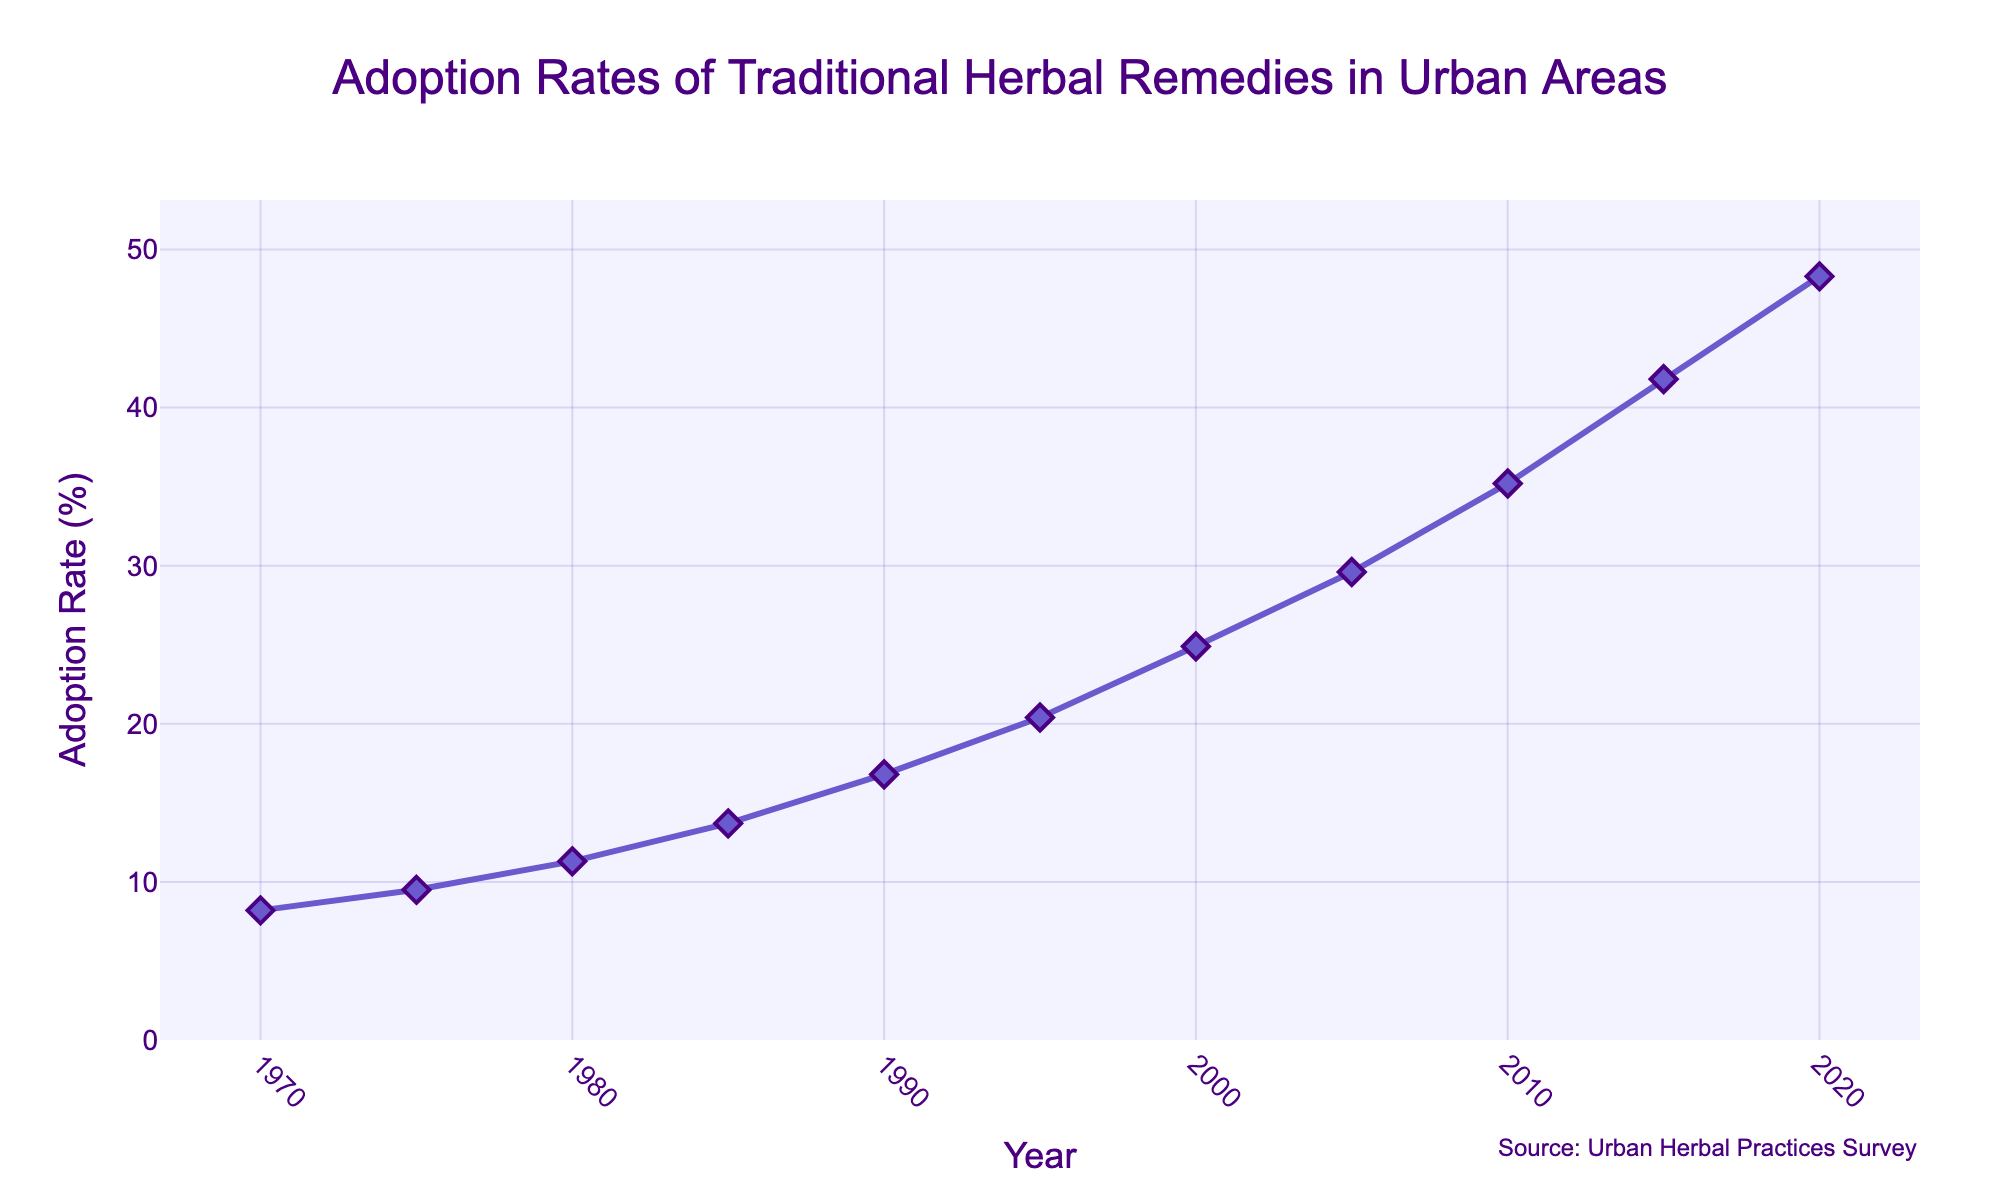What's the overall trend of the adoption rate of traditional herbal remedies in urban areas over the past 50 years? The line chart shows a consistent upward trend in the adoption rate of traditional herbal remedies from 1970 to 2020. Each segment between data points shows an increase without any decline.
Answer: Increasing In which decade did the adoption rate of traditional herbal remedies increase the most? To determine the decade with the highest increase, subtract the adoption rate of the starting year of each decade from the ending year. The decade with the largest difference is the one with the most significant increase. 2010-2020 shows the highest increase (48.3% - 35.2% = 13.1%).
Answer: 2010-2020 What was the adoption rate in the year 2000? Refer to the line plot and locate the point at the year 2000 on the x-axis, then look up the corresponding adoption rate on the y-axis. The adoption rate in 2000 was 24.9%.
Answer: 24.9% How much did the adoption rate increase from 1990 to 2020? Subtract the adoption rate in 1990 from the adoption rate in 2020: 48.3% - 16.8% = 31.5%.
Answer: 31.5% Compare the adoption rate in 1970 to that in 2020. Locate the adoption rates for 1970 and 2020 on the y-axis. The adoption rate was 8.2% in 1970 and 48.3% in 2020, indicating a substantial increase.
Answer: 1970 < 2020 What is the average adoption rate across all the years provided? Sum all the provided adoption rates and then divide by the total number of years. i.e., (8.2 + 9.5 + 11.3 + 13.7 + 16.8 + 20.4 + 24.9 + 29.6 + 35.2 + 41.8 + 48.3) / 11 = 25.36%.
Answer: 25.36% Between which consecutive years did the adoption rate grow the fastest? To find the fastest growth, examine the segments between consecutive years and find the pair with the largest difference in adoption rate. The largest difference is between 2015 and 2020 (48.3% - 41.8% = 6.5%).
Answer: 2015-2020 What is the adoption rate at the midpoint of the timeline, in 1995? Locate 1995 on the x-axis and refer to the corresponding value on the y-axis. The adoption rate in 1995 was 20.4%.
Answer: 20.4% How does the visual appearance of the plot emphasize the upward trend? The plotted data points are connected by a line that ascends from left to right, with markers accentuating each data point and the continuous rise in values. The line and markers' color and size make the trend visually prominent.
Answer: Ascending line with markers 